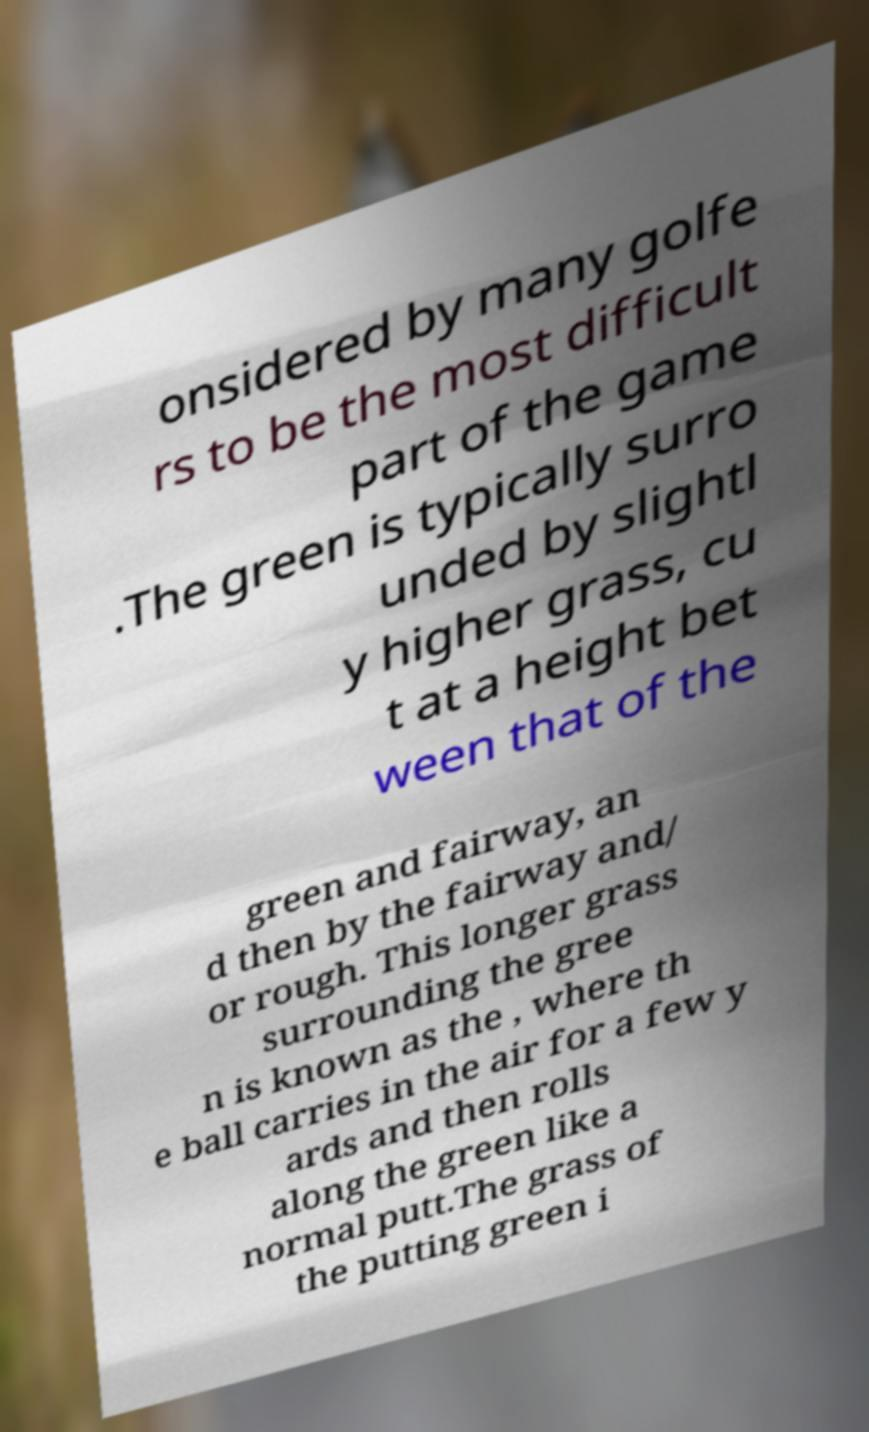What messages or text are displayed in this image? I need them in a readable, typed format. onsidered by many golfe rs to be the most difficult part of the game .The green is typically surro unded by slightl y higher grass, cu t at a height bet ween that of the green and fairway, an d then by the fairway and/ or rough. This longer grass surrounding the gree n is known as the , where th e ball carries in the air for a few y ards and then rolls along the green like a normal putt.The grass of the putting green i 